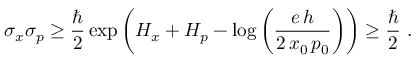Convert formula to latex. <formula><loc_0><loc_0><loc_500><loc_500>\sigma _ { x } \sigma _ { p } \geq { \frac { } { 2 } } \exp \left ( H _ { x } + H _ { p } - \log \left ( { \frac { e \, h } { 2 \, x _ { 0 } \, p _ { 0 } } } \right ) \right ) \geq { \frac { } { 2 } } .</formula> 